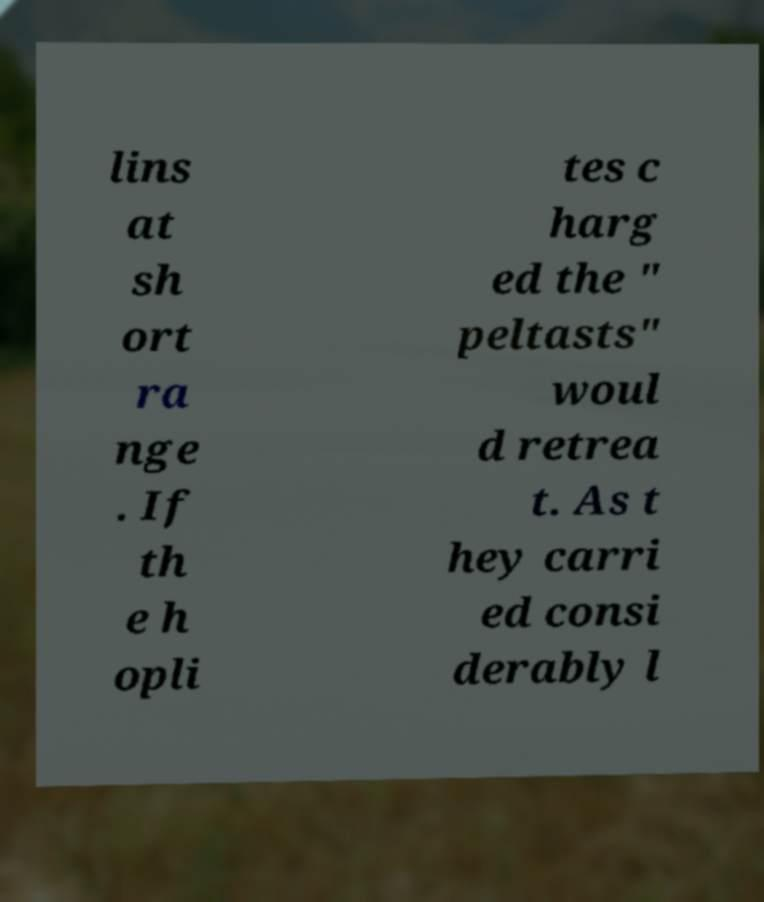Can you accurately transcribe the text from the provided image for me? lins at sh ort ra nge . If th e h opli tes c harg ed the " peltasts" woul d retrea t. As t hey carri ed consi derably l 